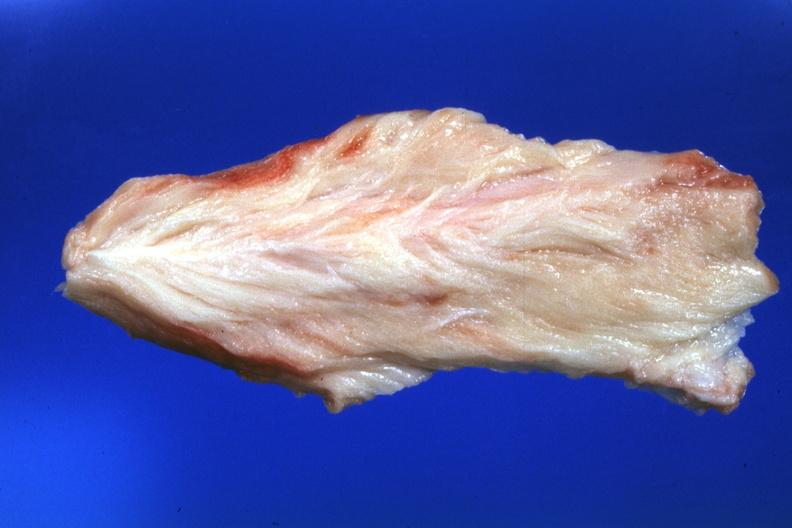does myocardial infarct show close-up very pale muscle?
Answer the question using a single word or phrase. No 